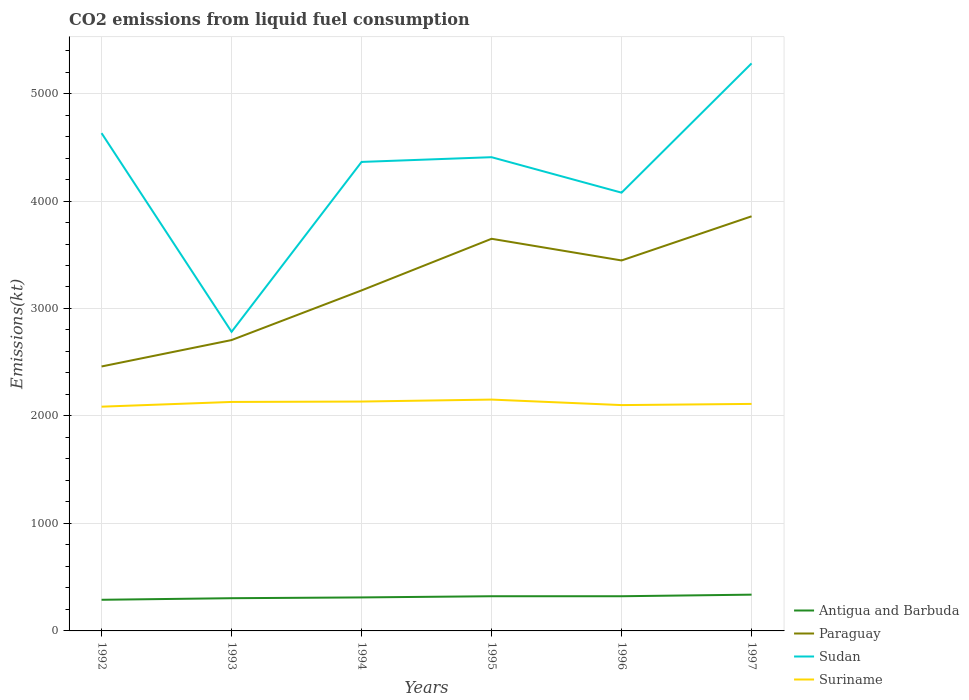How many different coloured lines are there?
Your response must be concise. 4. Does the line corresponding to Paraguay intersect with the line corresponding to Antigua and Barbuda?
Provide a succinct answer. No. Across all years, what is the maximum amount of CO2 emitted in Suriname?
Your answer should be very brief. 2086.52. What is the total amount of CO2 emitted in Sudan in the graph?
Give a very brief answer. -916.75. What is the difference between the highest and the second highest amount of CO2 emitted in Sudan?
Provide a short and direct response. 2497.23. What is the difference between the highest and the lowest amount of CO2 emitted in Sudan?
Your answer should be compact. 4. Is the amount of CO2 emitted in Paraguay strictly greater than the amount of CO2 emitted in Antigua and Barbuda over the years?
Your answer should be compact. No. How many years are there in the graph?
Offer a terse response. 6. Are the values on the major ticks of Y-axis written in scientific E-notation?
Your answer should be compact. No. Does the graph contain any zero values?
Your answer should be very brief. No. Does the graph contain grids?
Ensure brevity in your answer.  Yes. How many legend labels are there?
Your response must be concise. 4. How are the legend labels stacked?
Your answer should be very brief. Vertical. What is the title of the graph?
Your response must be concise. CO2 emissions from liquid fuel consumption. Does "Philippines" appear as one of the legend labels in the graph?
Your answer should be compact. No. What is the label or title of the Y-axis?
Your answer should be compact. Emissions(kt). What is the Emissions(kt) in Antigua and Barbuda in 1992?
Give a very brief answer. 289.69. What is the Emissions(kt) of Paraguay in 1992?
Keep it short and to the point. 2460.56. What is the Emissions(kt) in Sudan in 1992?
Offer a very short reply. 4631.42. What is the Emissions(kt) of Suriname in 1992?
Your answer should be compact. 2086.52. What is the Emissions(kt) of Antigua and Barbuda in 1993?
Ensure brevity in your answer.  304.36. What is the Emissions(kt) of Paraguay in 1993?
Provide a short and direct response. 2706.25. What is the Emissions(kt) of Sudan in 1993?
Your answer should be compact. 2783.25. What is the Emissions(kt) of Suriname in 1993?
Give a very brief answer. 2130.53. What is the Emissions(kt) of Antigua and Barbuda in 1994?
Make the answer very short. 311.69. What is the Emissions(kt) in Paraguay in 1994?
Offer a very short reply. 3168.29. What is the Emissions(kt) in Sudan in 1994?
Offer a terse response. 4363.73. What is the Emissions(kt) of Suriname in 1994?
Offer a terse response. 2134.19. What is the Emissions(kt) of Antigua and Barbuda in 1995?
Offer a terse response. 322.7. What is the Emissions(kt) in Paraguay in 1995?
Make the answer very short. 3648.66. What is the Emissions(kt) in Sudan in 1995?
Your answer should be compact. 4407.73. What is the Emissions(kt) of Suriname in 1995?
Give a very brief answer. 2152.53. What is the Emissions(kt) in Antigua and Barbuda in 1996?
Your response must be concise. 322.7. What is the Emissions(kt) in Paraguay in 1996?
Your answer should be compact. 3446.98. What is the Emissions(kt) of Sudan in 1996?
Provide a succinct answer. 4077.7. What is the Emissions(kt) of Suriname in 1996?
Give a very brief answer. 2101.19. What is the Emissions(kt) in Antigua and Barbuda in 1997?
Offer a terse response. 337.36. What is the Emissions(kt) in Paraguay in 1997?
Provide a short and direct response. 3857.68. What is the Emissions(kt) of Sudan in 1997?
Make the answer very short. 5280.48. What is the Emissions(kt) in Suriname in 1997?
Your answer should be very brief. 2112.19. Across all years, what is the maximum Emissions(kt) of Antigua and Barbuda?
Your response must be concise. 337.36. Across all years, what is the maximum Emissions(kt) of Paraguay?
Offer a very short reply. 3857.68. Across all years, what is the maximum Emissions(kt) in Sudan?
Make the answer very short. 5280.48. Across all years, what is the maximum Emissions(kt) in Suriname?
Keep it short and to the point. 2152.53. Across all years, what is the minimum Emissions(kt) of Antigua and Barbuda?
Your response must be concise. 289.69. Across all years, what is the minimum Emissions(kt) of Paraguay?
Ensure brevity in your answer.  2460.56. Across all years, what is the minimum Emissions(kt) of Sudan?
Your answer should be very brief. 2783.25. Across all years, what is the minimum Emissions(kt) of Suriname?
Offer a very short reply. 2086.52. What is the total Emissions(kt) in Antigua and Barbuda in the graph?
Your response must be concise. 1888.51. What is the total Emissions(kt) of Paraguay in the graph?
Your answer should be very brief. 1.93e+04. What is the total Emissions(kt) in Sudan in the graph?
Provide a short and direct response. 2.55e+04. What is the total Emissions(kt) in Suriname in the graph?
Keep it short and to the point. 1.27e+04. What is the difference between the Emissions(kt) of Antigua and Barbuda in 1992 and that in 1993?
Your response must be concise. -14.67. What is the difference between the Emissions(kt) in Paraguay in 1992 and that in 1993?
Offer a very short reply. -245.69. What is the difference between the Emissions(kt) in Sudan in 1992 and that in 1993?
Provide a short and direct response. 1848.17. What is the difference between the Emissions(kt) of Suriname in 1992 and that in 1993?
Offer a terse response. -44. What is the difference between the Emissions(kt) in Antigua and Barbuda in 1992 and that in 1994?
Give a very brief answer. -22. What is the difference between the Emissions(kt) in Paraguay in 1992 and that in 1994?
Give a very brief answer. -707.73. What is the difference between the Emissions(kt) of Sudan in 1992 and that in 1994?
Ensure brevity in your answer.  267.69. What is the difference between the Emissions(kt) in Suriname in 1992 and that in 1994?
Provide a succinct answer. -47.67. What is the difference between the Emissions(kt) of Antigua and Barbuda in 1992 and that in 1995?
Your answer should be compact. -33. What is the difference between the Emissions(kt) in Paraguay in 1992 and that in 1995?
Make the answer very short. -1188.11. What is the difference between the Emissions(kt) of Sudan in 1992 and that in 1995?
Provide a short and direct response. 223.69. What is the difference between the Emissions(kt) of Suriname in 1992 and that in 1995?
Offer a very short reply. -66.01. What is the difference between the Emissions(kt) in Antigua and Barbuda in 1992 and that in 1996?
Give a very brief answer. -33. What is the difference between the Emissions(kt) in Paraguay in 1992 and that in 1996?
Offer a very short reply. -986.42. What is the difference between the Emissions(kt) of Sudan in 1992 and that in 1996?
Your answer should be compact. 553.72. What is the difference between the Emissions(kt) of Suriname in 1992 and that in 1996?
Your answer should be very brief. -14.67. What is the difference between the Emissions(kt) in Antigua and Barbuda in 1992 and that in 1997?
Give a very brief answer. -47.67. What is the difference between the Emissions(kt) of Paraguay in 1992 and that in 1997?
Your response must be concise. -1397.13. What is the difference between the Emissions(kt) of Sudan in 1992 and that in 1997?
Offer a very short reply. -649.06. What is the difference between the Emissions(kt) of Suriname in 1992 and that in 1997?
Provide a succinct answer. -25.67. What is the difference between the Emissions(kt) in Antigua and Barbuda in 1993 and that in 1994?
Your answer should be very brief. -7.33. What is the difference between the Emissions(kt) in Paraguay in 1993 and that in 1994?
Offer a terse response. -462.04. What is the difference between the Emissions(kt) in Sudan in 1993 and that in 1994?
Your response must be concise. -1580.48. What is the difference between the Emissions(kt) of Suriname in 1993 and that in 1994?
Give a very brief answer. -3.67. What is the difference between the Emissions(kt) in Antigua and Barbuda in 1993 and that in 1995?
Offer a very short reply. -18.34. What is the difference between the Emissions(kt) of Paraguay in 1993 and that in 1995?
Provide a succinct answer. -942.42. What is the difference between the Emissions(kt) of Sudan in 1993 and that in 1995?
Offer a very short reply. -1624.48. What is the difference between the Emissions(kt) in Suriname in 1993 and that in 1995?
Provide a succinct answer. -22. What is the difference between the Emissions(kt) in Antigua and Barbuda in 1993 and that in 1996?
Your response must be concise. -18.34. What is the difference between the Emissions(kt) of Paraguay in 1993 and that in 1996?
Offer a very short reply. -740.73. What is the difference between the Emissions(kt) in Sudan in 1993 and that in 1996?
Your answer should be compact. -1294.45. What is the difference between the Emissions(kt) in Suriname in 1993 and that in 1996?
Provide a succinct answer. 29.34. What is the difference between the Emissions(kt) of Antigua and Barbuda in 1993 and that in 1997?
Keep it short and to the point. -33. What is the difference between the Emissions(kt) in Paraguay in 1993 and that in 1997?
Provide a succinct answer. -1151.44. What is the difference between the Emissions(kt) in Sudan in 1993 and that in 1997?
Make the answer very short. -2497.23. What is the difference between the Emissions(kt) in Suriname in 1993 and that in 1997?
Your answer should be compact. 18.34. What is the difference between the Emissions(kt) of Antigua and Barbuda in 1994 and that in 1995?
Give a very brief answer. -11. What is the difference between the Emissions(kt) of Paraguay in 1994 and that in 1995?
Your answer should be very brief. -480.38. What is the difference between the Emissions(kt) in Sudan in 1994 and that in 1995?
Offer a terse response. -44. What is the difference between the Emissions(kt) in Suriname in 1994 and that in 1995?
Your answer should be compact. -18.34. What is the difference between the Emissions(kt) of Antigua and Barbuda in 1994 and that in 1996?
Your answer should be compact. -11. What is the difference between the Emissions(kt) in Paraguay in 1994 and that in 1996?
Keep it short and to the point. -278.69. What is the difference between the Emissions(kt) in Sudan in 1994 and that in 1996?
Offer a terse response. 286.03. What is the difference between the Emissions(kt) in Suriname in 1994 and that in 1996?
Provide a short and direct response. 33. What is the difference between the Emissions(kt) in Antigua and Barbuda in 1994 and that in 1997?
Provide a succinct answer. -25.67. What is the difference between the Emissions(kt) in Paraguay in 1994 and that in 1997?
Offer a terse response. -689.4. What is the difference between the Emissions(kt) in Sudan in 1994 and that in 1997?
Give a very brief answer. -916.75. What is the difference between the Emissions(kt) in Suriname in 1994 and that in 1997?
Your answer should be very brief. 22. What is the difference between the Emissions(kt) of Antigua and Barbuda in 1995 and that in 1996?
Provide a succinct answer. 0. What is the difference between the Emissions(kt) of Paraguay in 1995 and that in 1996?
Keep it short and to the point. 201.69. What is the difference between the Emissions(kt) in Sudan in 1995 and that in 1996?
Make the answer very short. 330.03. What is the difference between the Emissions(kt) of Suriname in 1995 and that in 1996?
Your answer should be compact. 51.34. What is the difference between the Emissions(kt) in Antigua and Barbuda in 1995 and that in 1997?
Provide a short and direct response. -14.67. What is the difference between the Emissions(kt) of Paraguay in 1995 and that in 1997?
Your answer should be very brief. -209.02. What is the difference between the Emissions(kt) in Sudan in 1995 and that in 1997?
Offer a very short reply. -872.75. What is the difference between the Emissions(kt) in Suriname in 1995 and that in 1997?
Make the answer very short. 40.34. What is the difference between the Emissions(kt) in Antigua and Barbuda in 1996 and that in 1997?
Your answer should be very brief. -14.67. What is the difference between the Emissions(kt) in Paraguay in 1996 and that in 1997?
Offer a terse response. -410.7. What is the difference between the Emissions(kt) in Sudan in 1996 and that in 1997?
Provide a short and direct response. -1202.78. What is the difference between the Emissions(kt) of Suriname in 1996 and that in 1997?
Keep it short and to the point. -11. What is the difference between the Emissions(kt) in Antigua and Barbuda in 1992 and the Emissions(kt) in Paraguay in 1993?
Provide a succinct answer. -2416.55. What is the difference between the Emissions(kt) in Antigua and Barbuda in 1992 and the Emissions(kt) in Sudan in 1993?
Make the answer very short. -2493.56. What is the difference between the Emissions(kt) of Antigua and Barbuda in 1992 and the Emissions(kt) of Suriname in 1993?
Ensure brevity in your answer.  -1840.83. What is the difference between the Emissions(kt) of Paraguay in 1992 and the Emissions(kt) of Sudan in 1993?
Your response must be concise. -322.7. What is the difference between the Emissions(kt) of Paraguay in 1992 and the Emissions(kt) of Suriname in 1993?
Offer a terse response. 330.03. What is the difference between the Emissions(kt) of Sudan in 1992 and the Emissions(kt) of Suriname in 1993?
Provide a short and direct response. 2500.89. What is the difference between the Emissions(kt) in Antigua and Barbuda in 1992 and the Emissions(kt) in Paraguay in 1994?
Your answer should be very brief. -2878.59. What is the difference between the Emissions(kt) of Antigua and Barbuda in 1992 and the Emissions(kt) of Sudan in 1994?
Your answer should be compact. -4074.04. What is the difference between the Emissions(kt) in Antigua and Barbuda in 1992 and the Emissions(kt) in Suriname in 1994?
Offer a terse response. -1844.5. What is the difference between the Emissions(kt) of Paraguay in 1992 and the Emissions(kt) of Sudan in 1994?
Make the answer very short. -1903.17. What is the difference between the Emissions(kt) in Paraguay in 1992 and the Emissions(kt) in Suriname in 1994?
Offer a terse response. 326.36. What is the difference between the Emissions(kt) in Sudan in 1992 and the Emissions(kt) in Suriname in 1994?
Provide a short and direct response. 2497.23. What is the difference between the Emissions(kt) of Antigua and Barbuda in 1992 and the Emissions(kt) of Paraguay in 1995?
Offer a very short reply. -3358.97. What is the difference between the Emissions(kt) in Antigua and Barbuda in 1992 and the Emissions(kt) in Sudan in 1995?
Ensure brevity in your answer.  -4118.04. What is the difference between the Emissions(kt) of Antigua and Barbuda in 1992 and the Emissions(kt) of Suriname in 1995?
Your answer should be very brief. -1862.84. What is the difference between the Emissions(kt) of Paraguay in 1992 and the Emissions(kt) of Sudan in 1995?
Keep it short and to the point. -1947.18. What is the difference between the Emissions(kt) of Paraguay in 1992 and the Emissions(kt) of Suriname in 1995?
Your answer should be very brief. 308.03. What is the difference between the Emissions(kt) in Sudan in 1992 and the Emissions(kt) in Suriname in 1995?
Provide a short and direct response. 2478.89. What is the difference between the Emissions(kt) of Antigua and Barbuda in 1992 and the Emissions(kt) of Paraguay in 1996?
Ensure brevity in your answer.  -3157.29. What is the difference between the Emissions(kt) in Antigua and Barbuda in 1992 and the Emissions(kt) in Sudan in 1996?
Offer a terse response. -3788.01. What is the difference between the Emissions(kt) of Antigua and Barbuda in 1992 and the Emissions(kt) of Suriname in 1996?
Keep it short and to the point. -1811.5. What is the difference between the Emissions(kt) of Paraguay in 1992 and the Emissions(kt) of Sudan in 1996?
Your response must be concise. -1617.15. What is the difference between the Emissions(kt) of Paraguay in 1992 and the Emissions(kt) of Suriname in 1996?
Offer a terse response. 359.37. What is the difference between the Emissions(kt) in Sudan in 1992 and the Emissions(kt) in Suriname in 1996?
Offer a terse response. 2530.23. What is the difference between the Emissions(kt) of Antigua and Barbuda in 1992 and the Emissions(kt) of Paraguay in 1997?
Keep it short and to the point. -3567.99. What is the difference between the Emissions(kt) in Antigua and Barbuda in 1992 and the Emissions(kt) in Sudan in 1997?
Your response must be concise. -4990.79. What is the difference between the Emissions(kt) in Antigua and Barbuda in 1992 and the Emissions(kt) in Suriname in 1997?
Make the answer very short. -1822.5. What is the difference between the Emissions(kt) of Paraguay in 1992 and the Emissions(kt) of Sudan in 1997?
Provide a succinct answer. -2819.92. What is the difference between the Emissions(kt) in Paraguay in 1992 and the Emissions(kt) in Suriname in 1997?
Your answer should be compact. 348.37. What is the difference between the Emissions(kt) in Sudan in 1992 and the Emissions(kt) in Suriname in 1997?
Keep it short and to the point. 2519.23. What is the difference between the Emissions(kt) in Antigua and Barbuda in 1993 and the Emissions(kt) in Paraguay in 1994?
Give a very brief answer. -2863.93. What is the difference between the Emissions(kt) of Antigua and Barbuda in 1993 and the Emissions(kt) of Sudan in 1994?
Provide a succinct answer. -4059.37. What is the difference between the Emissions(kt) of Antigua and Barbuda in 1993 and the Emissions(kt) of Suriname in 1994?
Provide a succinct answer. -1829.83. What is the difference between the Emissions(kt) of Paraguay in 1993 and the Emissions(kt) of Sudan in 1994?
Offer a terse response. -1657.48. What is the difference between the Emissions(kt) of Paraguay in 1993 and the Emissions(kt) of Suriname in 1994?
Offer a very short reply. 572.05. What is the difference between the Emissions(kt) in Sudan in 1993 and the Emissions(kt) in Suriname in 1994?
Keep it short and to the point. 649.06. What is the difference between the Emissions(kt) of Antigua and Barbuda in 1993 and the Emissions(kt) of Paraguay in 1995?
Offer a terse response. -3344.3. What is the difference between the Emissions(kt) of Antigua and Barbuda in 1993 and the Emissions(kt) of Sudan in 1995?
Make the answer very short. -4103.37. What is the difference between the Emissions(kt) of Antigua and Barbuda in 1993 and the Emissions(kt) of Suriname in 1995?
Offer a terse response. -1848.17. What is the difference between the Emissions(kt) of Paraguay in 1993 and the Emissions(kt) of Sudan in 1995?
Your answer should be compact. -1701.49. What is the difference between the Emissions(kt) in Paraguay in 1993 and the Emissions(kt) in Suriname in 1995?
Provide a succinct answer. 553.72. What is the difference between the Emissions(kt) of Sudan in 1993 and the Emissions(kt) of Suriname in 1995?
Your response must be concise. 630.72. What is the difference between the Emissions(kt) of Antigua and Barbuda in 1993 and the Emissions(kt) of Paraguay in 1996?
Your response must be concise. -3142.62. What is the difference between the Emissions(kt) in Antigua and Barbuda in 1993 and the Emissions(kt) in Sudan in 1996?
Your response must be concise. -3773.34. What is the difference between the Emissions(kt) in Antigua and Barbuda in 1993 and the Emissions(kt) in Suriname in 1996?
Provide a short and direct response. -1796.83. What is the difference between the Emissions(kt) in Paraguay in 1993 and the Emissions(kt) in Sudan in 1996?
Your response must be concise. -1371.46. What is the difference between the Emissions(kt) of Paraguay in 1993 and the Emissions(kt) of Suriname in 1996?
Offer a very short reply. 605.05. What is the difference between the Emissions(kt) in Sudan in 1993 and the Emissions(kt) in Suriname in 1996?
Offer a terse response. 682.06. What is the difference between the Emissions(kt) in Antigua and Barbuda in 1993 and the Emissions(kt) in Paraguay in 1997?
Make the answer very short. -3553.32. What is the difference between the Emissions(kt) in Antigua and Barbuda in 1993 and the Emissions(kt) in Sudan in 1997?
Ensure brevity in your answer.  -4976.12. What is the difference between the Emissions(kt) of Antigua and Barbuda in 1993 and the Emissions(kt) of Suriname in 1997?
Your answer should be compact. -1807.83. What is the difference between the Emissions(kt) in Paraguay in 1993 and the Emissions(kt) in Sudan in 1997?
Make the answer very short. -2574.23. What is the difference between the Emissions(kt) in Paraguay in 1993 and the Emissions(kt) in Suriname in 1997?
Keep it short and to the point. 594.05. What is the difference between the Emissions(kt) in Sudan in 1993 and the Emissions(kt) in Suriname in 1997?
Offer a very short reply. 671.06. What is the difference between the Emissions(kt) of Antigua and Barbuda in 1994 and the Emissions(kt) of Paraguay in 1995?
Your answer should be very brief. -3336.97. What is the difference between the Emissions(kt) of Antigua and Barbuda in 1994 and the Emissions(kt) of Sudan in 1995?
Offer a very short reply. -4096.04. What is the difference between the Emissions(kt) of Antigua and Barbuda in 1994 and the Emissions(kt) of Suriname in 1995?
Provide a short and direct response. -1840.83. What is the difference between the Emissions(kt) of Paraguay in 1994 and the Emissions(kt) of Sudan in 1995?
Your answer should be compact. -1239.45. What is the difference between the Emissions(kt) in Paraguay in 1994 and the Emissions(kt) in Suriname in 1995?
Offer a very short reply. 1015.76. What is the difference between the Emissions(kt) of Sudan in 1994 and the Emissions(kt) of Suriname in 1995?
Keep it short and to the point. 2211.2. What is the difference between the Emissions(kt) of Antigua and Barbuda in 1994 and the Emissions(kt) of Paraguay in 1996?
Your response must be concise. -3135.28. What is the difference between the Emissions(kt) in Antigua and Barbuda in 1994 and the Emissions(kt) in Sudan in 1996?
Offer a very short reply. -3766.01. What is the difference between the Emissions(kt) of Antigua and Barbuda in 1994 and the Emissions(kt) of Suriname in 1996?
Your answer should be very brief. -1789.5. What is the difference between the Emissions(kt) in Paraguay in 1994 and the Emissions(kt) in Sudan in 1996?
Ensure brevity in your answer.  -909.42. What is the difference between the Emissions(kt) of Paraguay in 1994 and the Emissions(kt) of Suriname in 1996?
Offer a very short reply. 1067.1. What is the difference between the Emissions(kt) in Sudan in 1994 and the Emissions(kt) in Suriname in 1996?
Keep it short and to the point. 2262.54. What is the difference between the Emissions(kt) of Antigua and Barbuda in 1994 and the Emissions(kt) of Paraguay in 1997?
Make the answer very short. -3545.99. What is the difference between the Emissions(kt) in Antigua and Barbuda in 1994 and the Emissions(kt) in Sudan in 1997?
Your answer should be very brief. -4968.78. What is the difference between the Emissions(kt) in Antigua and Barbuda in 1994 and the Emissions(kt) in Suriname in 1997?
Provide a succinct answer. -1800.5. What is the difference between the Emissions(kt) in Paraguay in 1994 and the Emissions(kt) in Sudan in 1997?
Your response must be concise. -2112.19. What is the difference between the Emissions(kt) in Paraguay in 1994 and the Emissions(kt) in Suriname in 1997?
Make the answer very short. 1056.1. What is the difference between the Emissions(kt) of Sudan in 1994 and the Emissions(kt) of Suriname in 1997?
Make the answer very short. 2251.54. What is the difference between the Emissions(kt) of Antigua and Barbuda in 1995 and the Emissions(kt) of Paraguay in 1996?
Offer a very short reply. -3124.28. What is the difference between the Emissions(kt) of Antigua and Barbuda in 1995 and the Emissions(kt) of Sudan in 1996?
Provide a short and direct response. -3755.01. What is the difference between the Emissions(kt) in Antigua and Barbuda in 1995 and the Emissions(kt) in Suriname in 1996?
Make the answer very short. -1778.49. What is the difference between the Emissions(kt) in Paraguay in 1995 and the Emissions(kt) in Sudan in 1996?
Offer a terse response. -429.04. What is the difference between the Emissions(kt) of Paraguay in 1995 and the Emissions(kt) of Suriname in 1996?
Your answer should be compact. 1547.47. What is the difference between the Emissions(kt) in Sudan in 1995 and the Emissions(kt) in Suriname in 1996?
Keep it short and to the point. 2306.54. What is the difference between the Emissions(kt) in Antigua and Barbuda in 1995 and the Emissions(kt) in Paraguay in 1997?
Make the answer very short. -3534.99. What is the difference between the Emissions(kt) in Antigua and Barbuda in 1995 and the Emissions(kt) in Sudan in 1997?
Give a very brief answer. -4957.78. What is the difference between the Emissions(kt) of Antigua and Barbuda in 1995 and the Emissions(kt) of Suriname in 1997?
Make the answer very short. -1789.5. What is the difference between the Emissions(kt) of Paraguay in 1995 and the Emissions(kt) of Sudan in 1997?
Offer a very short reply. -1631.82. What is the difference between the Emissions(kt) of Paraguay in 1995 and the Emissions(kt) of Suriname in 1997?
Your answer should be very brief. 1536.47. What is the difference between the Emissions(kt) in Sudan in 1995 and the Emissions(kt) in Suriname in 1997?
Your answer should be very brief. 2295.54. What is the difference between the Emissions(kt) in Antigua and Barbuda in 1996 and the Emissions(kt) in Paraguay in 1997?
Your answer should be compact. -3534.99. What is the difference between the Emissions(kt) of Antigua and Barbuda in 1996 and the Emissions(kt) of Sudan in 1997?
Make the answer very short. -4957.78. What is the difference between the Emissions(kt) of Antigua and Barbuda in 1996 and the Emissions(kt) of Suriname in 1997?
Offer a terse response. -1789.5. What is the difference between the Emissions(kt) in Paraguay in 1996 and the Emissions(kt) in Sudan in 1997?
Offer a very short reply. -1833.5. What is the difference between the Emissions(kt) in Paraguay in 1996 and the Emissions(kt) in Suriname in 1997?
Offer a very short reply. 1334.79. What is the difference between the Emissions(kt) in Sudan in 1996 and the Emissions(kt) in Suriname in 1997?
Give a very brief answer. 1965.51. What is the average Emissions(kt) of Antigua and Barbuda per year?
Your answer should be very brief. 314.75. What is the average Emissions(kt) of Paraguay per year?
Your answer should be compact. 3214.74. What is the average Emissions(kt) of Sudan per year?
Offer a terse response. 4257.39. What is the average Emissions(kt) of Suriname per year?
Provide a short and direct response. 2119.53. In the year 1992, what is the difference between the Emissions(kt) of Antigua and Barbuda and Emissions(kt) of Paraguay?
Your answer should be very brief. -2170.86. In the year 1992, what is the difference between the Emissions(kt) in Antigua and Barbuda and Emissions(kt) in Sudan?
Offer a terse response. -4341.73. In the year 1992, what is the difference between the Emissions(kt) in Antigua and Barbuda and Emissions(kt) in Suriname?
Offer a terse response. -1796.83. In the year 1992, what is the difference between the Emissions(kt) of Paraguay and Emissions(kt) of Sudan?
Your response must be concise. -2170.86. In the year 1992, what is the difference between the Emissions(kt) in Paraguay and Emissions(kt) in Suriname?
Offer a terse response. 374.03. In the year 1992, what is the difference between the Emissions(kt) in Sudan and Emissions(kt) in Suriname?
Ensure brevity in your answer.  2544.9. In the year 1993, what is the difference between the Emissions(kt) of Antigua and Barbuda and Emissions(kt) of Paraguay?
Provide a succinct answer. -2401.89. In the year 1993, what is the difference between the Emissions(kt) in Antigua and Barbuda and Emissions(kt) in Sudan?
Give a very brief answer. -2478.89. In the year 1993, what is the difference between the Emissions(kt) in Antigua and Barbuda and Emissions(kt) in Suriname?
Give a very brief answer. -1826.17. In the year 1993, what is the difference between the Emissions(kt) in Paraguay and Emissions(kt) in Sudan?
Offer a terse response. -77.01. In the year 1993, what is the difference between the Emissions(kt) of Paraguay and Emissions(kt) of Suriname?
Your answer should be very brief. 575.72. In the year 1993, what is the difference between the Emissions(kt) in Sudan and Emissions(kt) in Suriname?
Offer a terse response. 652.73. In the year 1994, what is the difference between the Emissions(kt) in Antigua and Barbuda and Emissions(kt) in Paraguay?
Offer a terse response. -2856.59. In the year 1994, what is the difference between the Emissions(kt) of Antigua and Barbuda and Emissions(kt) of Sudan?
Your response must be concise. -4052.03. In the year 1994, what is the difference between the Emissions(kt) of Antigua and Barbuda and Emissions(kt) of Suriname?
Offer a very short reply. -1822.5. In the year 1994, what is the difference between the Emissions(kt) of Paraguay and Emissions(kt) of Sudan?
Keep it short and to the point. -1195.44. In the year 1994, what is the difference between the Emissions(kt) in Paraguay and Emissions(kt) in Suriname?
Offer a terse response. 1034.09. In the year 1994, what is the difference between the Emissions(kt) of Sudan and Emissions(kt) of Suriname?
Your response must be concise. 2229.54. In the year 1995, what is the difference between the Emissions(kt) of Antigua and Barbuda and Emissions(kt) of Paraguay?
Provide a succinct answer. -3325.97. In the year 1995, what is the difference between the Emissions(kt) in Antigua and Barbuda and Emissions(kt) in Sudan?
Provide a succinct answer. -4085.04. In the year 1995, what is the difference between the Emissions(kt) of Antigua and Barbuda and Emissions(kt) of Suriname?
Give a very brief answer. -1829.83. In the year 1995, what is the difference between the Emissions(kt) in Paraguay and Emissions(kt) in Sudan?
Provide a short and direct response. -759.07. In the year 1995, what is the difference between the Emissions(kt) in Paraguay and Emissions(kt) in Suriname?
Provide a short and direct response. 1496.14. In the year 1995, what is the difference between the Emissions(kt) in Sudan and Emissions(kt) in Suriname?
Make the answer very short. 2255.2. In the year 1996, what is the difference between the Emissions(kt) of Antigua and Barbuda and Emissions(kt) of Paraguay?
Provide a short and direct response. -3124.28. In the year 1996, what is the difference between the Emissions(kt) of Antigua and Barbuda and Emissions(kt) of Sudan?
Offer a terse response. -3755.01. In the year 1996, what is the difference between the Emissions(kt) of Antigua and Barbuda and Emissions(kt) of Suriname?
Your response must be concise. -1778.49. In the year 1996, what is the difference between the Emissions(kt) of Paraguay and Emissions(kt) of Sudan?
Make the answer very short. -630.72. In the year 1996, what is the difference between the Emissions(kt) of Paraguay and Emissions(kt) of Suriname?
Give a very brief answer. 1345.79. In the year 1996, what is the difference between the Emissions(kt) in Sudan and Emissions(kt) in Suriname?
Ensure brevity in your answer.  1976.51. In the year 1997, what is the difference between the Emissions(kt) in Antigua and Barbuda and Emissions(kt) in Paraguay?
Provide a short and direct response. -3520.32. In the year 1997, what is the difference between the Emissions(kt) of Antigua and Barbuda and Emissions(kt) of Sudan?
Ensure brevity in your answer.  -4943.12. In the year 1997, what is the difference between the Emissions(kt) in Antigua and Barbuda and Emissions(kt) in Suriname?
Your response must be concise. -1774.83. In the year 1997, what is the difference between the Emissions(kt) of Paraguay and Emissions(kt) of Sudan?
Make the answer very short. -1422.8. In the year 1997, what is the difference between the Emissions(kt) of Paraguay and Emissions(kt) of Suriname?
Your answer should be very brief. 1745.49. In the year 1997, what is the difference between the Emissions(kt) of Sudan and Emissions(kt) of Suriname?
Offer a very short reply. 3168.29. What is the ratio of the Emissions(kt) in Antigua and Barbuda in 1992 to that in 1993?
Ensure brevity in your answer.  0.95. What is the ratio of the Emissions(kt) in Paraguay in 1992 to that in 1993?
Your response must be concise. 0.91. What is the ratio of the Emissions(kt) in Sudan in 1992 to that in 1993?
Your response must be concise. 1.66. What is the ratio of the Emissions(kt) of Suriname in 1992 to that in 1993?
Give a very brief answer. 0.98. What is the ratio of the Emissions(kt) of Antigua and Barbuda in 1992 to that in 1994?
Keep it short and to the point. 0.93. What is the ratio of the Emissions(kt) of Paraguay in 1992 to that in 1994?
Offer a terse response. 0.78. What is the ratio of the Emissions(kt) in Sudan in 1992 to that in 1994?
Your answer should be compact. 1.06. What is the ratio of the Emissions(kt) in Suriname in 1992 to that in 1994?
Offer a very short reply. 0.98. What is the ratio of the Emissions(kt) in Antigua and Barbuda in 1992 to that in 1995?
Provide a succinct answer. 0.9. What is the ratio of the Emissions(kt) of Paraguay in 1992 to that in 1995?
Give a very brief answer. 0.67. What is the ratio of the Emissions(kt) of Sudan in 1992 to that in 1995?
Keep it short and to the point. 1.05. What is the ratio of the Emissions(kt) of Suriname in 1992 to that in 1995?
Offer a very short reply. 0.97. What is the ratio of the Emissions(kt) of Antigua and Barbuda in 1992 to that in 1996?
Your answer should be very brief. 0.9. What is the ratio of the Emissions(kt) in Paraguay in 1992 to that in 1996?
Give a very brief answer. 0.71. What is the ratio of the Emissions(kt) in Sudan in 1992 to that in 1996?
Provide a succinct answer. 1.14. What is the ratio of the Emissions(kt) in Antigua and Barbuda in 1992 to that in 1997?
Keep it short and to the point. 0.86. What is the ratio of the Emissions(kt) in Paraguay in 1992 to that in 1997?
Make the answer very short. 0.64. What is the ratio of the Emissions(kt) in Sudan in 1992 to that in 1997?
Your answer should be compact. 0.88. What is the ratio of the Emissions(kt) of Suriname in 1992 to that in 1997?
Your answer should be compact. 0.99. What is the ratio of the Emissions(kt) in Antigua and Barbuda in 1993 to that in 1994?
Provide a short and direct response. 0.98. What is the ratio of the Emissions(kt) of Paraguay in 1993 to that in 1994?
Ensure brevity in your answer.  0.85. What is the ratio of the Emissions(kt) in Sudan in 1993 to that in 1994?
Keep it short and to the point. 0.64. What is the ratio of the Emissions(kt) in Antigua and Barbuda in 1993 to that in 1995?
Give a very brief answer. 0.94. What is the ratio of the Emissions(kt) in Paraguay in 1993 to that in 1995?
Provide a short and direct response. 0.74. What is the ratio of the Emissions(kt) in Sudan in 1993 to that in 1995?
Keep it short and to the point. 0.63. What is the ratio of the Emissions(kt) of Suriname in 1993 to that in 1995?
Keep it short and to the point. 0.99. What is the ratio of the Emissions(kt) in Antigua and Barbuda in 1993 to that in 1996?
Your answer should be compact. 0.94. What is the ratio of the Emissions(kt) of Paraguay in 1993 to that in 1996?
Offer a terse response. 0.79. What is the ratio of the Emissions(kt) of Sudan in 1993 to that in 1996?
Your answer should be compact. 0.68. What is the ratio of the Emissions(kt) in Antigua and Barbuda in 1993 to that in 1997?
Provide a succinct answer. 0.9. What is the ratio of the Emissions(kt) in Paraguay in 1993 to that in 1997?
Offer a terse response. 0.7. What is the ratio of the Emissions(kt) of Sudan in 1993 to that in 1997?
Provide a short and direct response. 0.53. What is the ratio of the Emissions(kt) in Suriname in 1993 to that in 1997?
Your response must be concise. 1.01. What is the ratio of the Emissions(kt) of Antigua and Barbuda in 1994 to that in 1995?
Offer a very short reply. 0.97. What is the ratio of the Emissions(kt) of Paraguay in 1994 to that in 1995?
Offer a terse response. 0.87. What is the ratio of the Emissions(kt) of Suriname in 1994 to that in 1995?
Provide a succinct answer. 0.99. What is the ratio of the Emissions(kt) of Antigua and Barbuda in 1994 to that in 1996?
Make the answer very short. 0.97. What is the ratio of the Emissions(kt) in Paraguay in 1994 to that in 1996?
Provide a succinct answer. 0.92. What is the ratio of the Emissions(kt) in Sudan in 1994 to that in 1996?
Ensure brevity in your answer.  1.07. What is the ratio of the Emissions(kt) in Suriname in 1994 to that in 1996?
Give a very brief answer. 1.02. What is the ratio of the Emissions(kt) of Antigua and Barbuda in 1994 to that in 1997?
Keep it short and to the point. 0.92. What is the ratio of the Emissions(kt) of Paraguay in 1994 to that in 1997?
Give a very brief answer. 0.82. What is the ratio of the Emissions(kt) of Sudan in 1994 to that in 1997?
Your answer should be compact. 0.83. What is the ratio of the Emissions(kt) in Suriname in 1994 to that in 1997?
Offer a terse response. 1.01. What is the ratio of the Emissions(kt) in Paraguay in 1995 to that in 1996?
Give a very brief answer. 1.06. What is the ratio of the Emissions(kt) in Sudan in 1995 to that in 1996?
Offer a terse response. 1.08. What is the ratio of the Emissions(kt) in Suriname in 1995 to that in 1996?
Keep it short and to the point. 1.02. What is the ratio of the Emissions(kt) of Antigua and Barbuda in 1995 to that in 1997?
Keep it short and to the point. 0.96. What is the ratio of the Emissions(kt) in Paraguay in 1995 to that in 1997?
Offer a terse response. 0.95. What is the ratio of the Emissions(kt) of Sudan in 1995 to that in 1997?
Keep it short and to the point. 0.83. What is the ratio of the Emissions(kt) in Suriname in 1995 to that in 1997?
Your response must be concise. 1.02. What is the ratio of the Emissions(kt) in Antigua and Barbuda in 1996 to that in 1997?
Your answer should be compact. 0.96. What is the ratio of the Emissions(kt) of Paraguay in 1996 to that in 1997?
Your answer should be compact. 0.89. What is the ratio of the Emissions(kt) in Sudan in 1996 to that in 1997?
Make the answer very short. 0.77. What is the ratio of the Emissions(kt) in Suriname in 1996 to that in 1997?
Offer a terse response. 0.99. What is the difference between the highest and the second highest Emissions(kt) in Antigua and Barbuda?
Ensure brevity in your answer.  14.67. What is the difference between the highest and the second highest Emissions(kt) in Paraguay?
Offer a very short reply. 209.02. What is the difference between the highest and the second highest Emissions(kt) of Sudan?
Your answer should be compact. 649.06. What is the difference between the highest and the second highest Emissions(kt) in Suriname?
Offer a terse response. 18.34. What is the difference between the highest and the lowest Emissions(kt) of Antigua and Barbuda?
Ensure brevity in your answer.  47.67. What is the difference between the highest and the lowest Emissions(kt) of Paraguay?
Give a very brief answer. 1397.13. What is the difference between the highest and the lowest Emissions(kt) in Sudan?
Give a very brief answer. 2497.23. What is the difference between the highest and the lowest Emissions(kt) in Suriname?
Your answer should be compact. 66.01. 